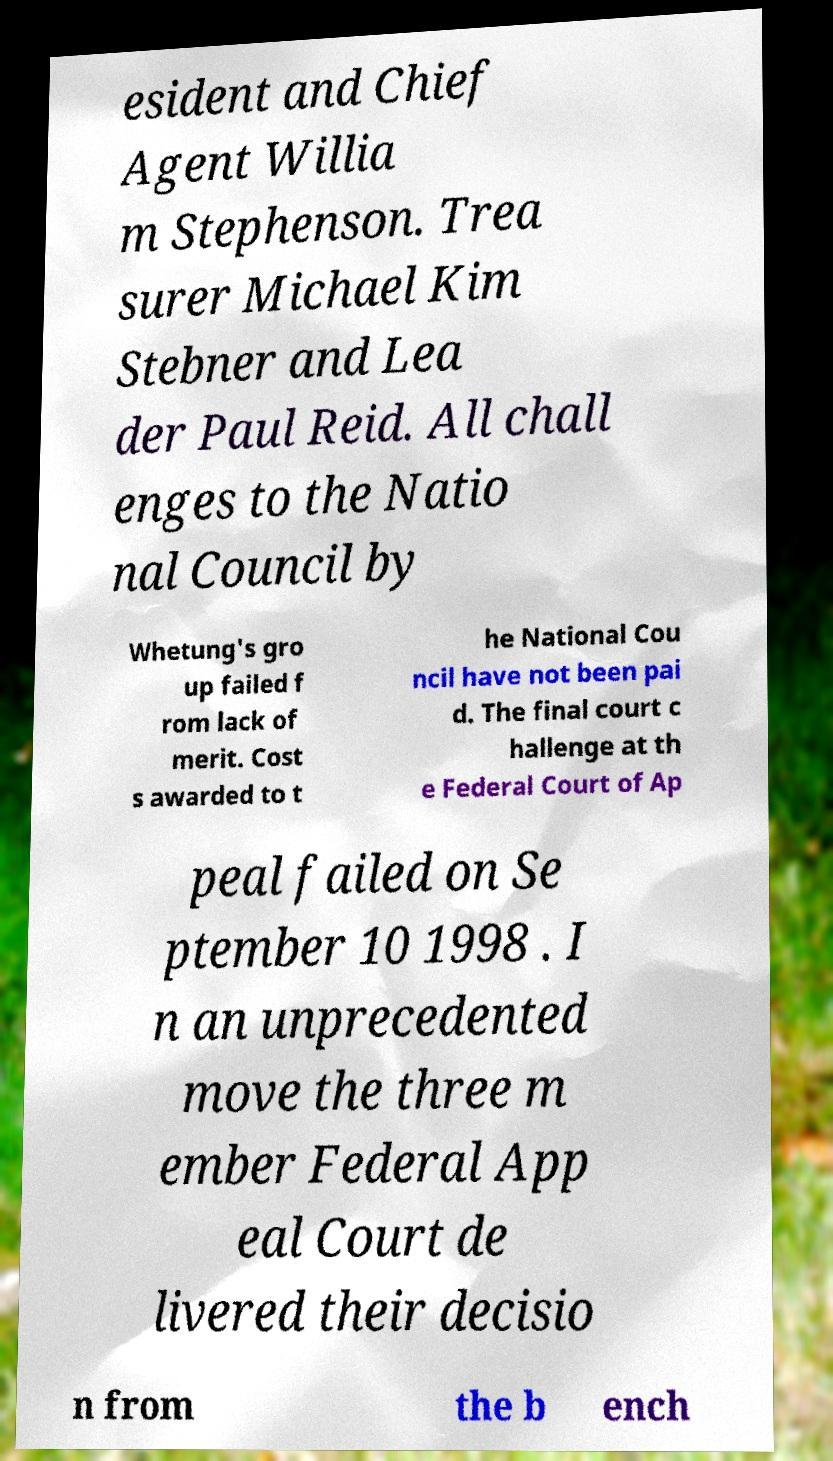Can you read and provide the text displayed in the image?This photo seems to have some interesting text. Can you extract and type it out for me? esident and Chief Agent Willia m Stephenson. Trea surer Michael Kim Stebner and Lea der Paul Reid. All chall enges to the Natio nal Council by Whetung's gro up failed f rom lack of merit. Cost s awarded to t he National Cou ncil have not been pai d. The final court c hallenge at th e Federal Court of Ap peal failed on Se ptember 10 1998 . I n an unprecedented move the three m ember Federal App eal Court de livered their decisio n from the b ench 